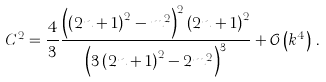<formula> <loc_0><loc_0><loc_500><loc_500>C ^ { 2 } = \frac { 4 } { 3 } \frac { \left ( \left ( 2 n + 1 \right ) ^ { 2 } - m ^ { 2 } \right ) ^ { 2 } \left ( 2 n + 1 \right ) ^ { 2 } } { \left ( 3 \left ( 2 n + 1 \right ) ^ { 2 } - 2 m ^ { 2 } \right ) ^ { 3 } } + \mathcal { O } \left ( k ^ { 4 } \right ) \, .</formula> 